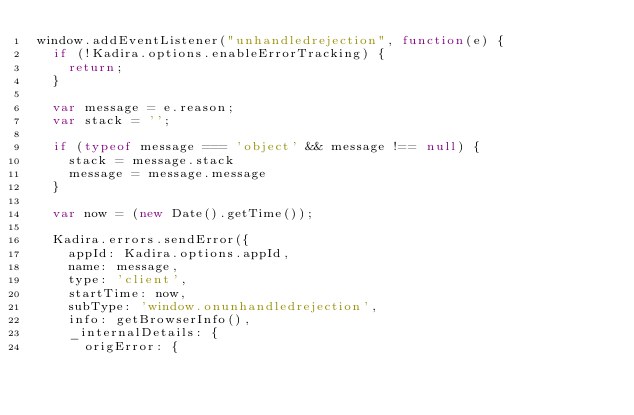<code> <loc_0><loc_0><loc_500><loc_500><_JavaScript_>window.addEventListener("unhandledrejection", function(e) {
  if (!Kadira.options.enableErrorTracking) {
    return;
  }

  var message = e.reason;
  var stack = '';

  if (typeof message === 'object' && message !== null) {
    stack = message.stack
    message = message.message
  }

  var now = (new Date().getTime());

  Kadira.errors.sendError({
    appId: Kadira.options.appId,
    name: message,
    type: 'client',
    startTime: now,
    subType: 'window.onunhandledrejection',
    info: getBrowserInfo(),
    _internalDetails: {
      origError: {</code> 